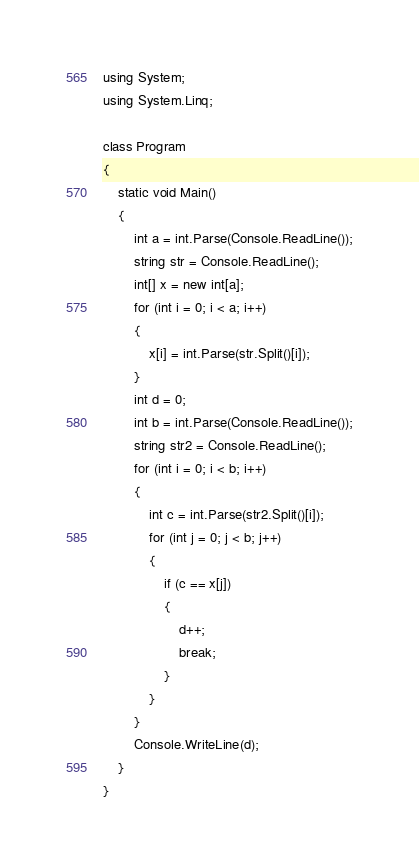Convert code to text. <code><loc_0><loc_0><loc_500><loc_500><_C#_>using System;
using System.Linq;

class Program
{
    static void Main()
    {
        int a = int.Parse(Console.ReadLine());
        string str = Console.ReadLine();
        int[] x = new int[a];
        for (int i = 0; i < a; i++)
        {
            x[i] = int.Parse(str.Split()[i]);
        }
        int d = 0;
        int b = int.Parse(Console.ReadLine());
        string str2 = Console.ReadLine();
        for (int i = 0; i < b; i++)
        {
            int c = int.Parse(str2.Split()[i]);
            for (int j = 0; j < b; j++)
            {
                if (c == x[j])
                {
                    d++;
                    break;
                }
            }
        }
        Console.WriteLine(d);
    }
}</code> 